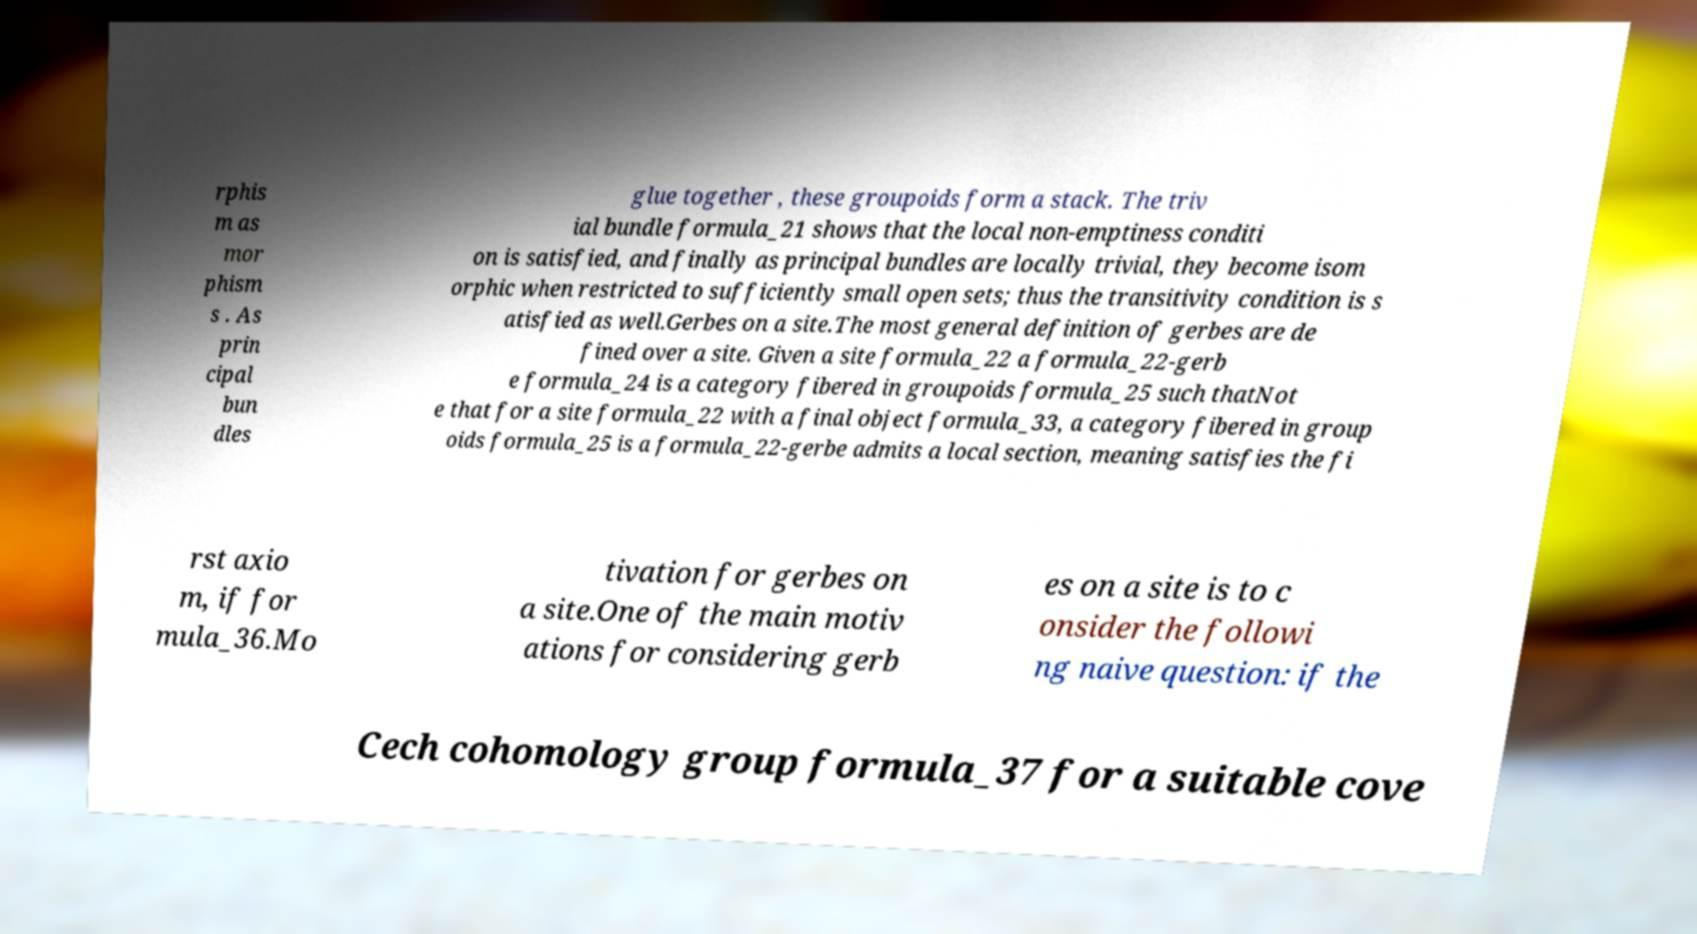I need the written content from this picture converted into text. Can you do that? rphis m as mor phism s . As prin cipal bun dles glue together , these groupoids form a stack. The triv ial bundle formula_21 shows that the local non-emptiness conditi on is satisfied, and finally as principal bundles are locally trivial, they become isom orphic when restricted to sufficiently small open sets; thus the transitivity condition is s atisfied as well.Gerbes on a site.The most general definition of gerbes are de fined over a site. Given a site formula_22 a formula_22-gerb e formula_24 is a category fibered in groupoids formula_25 such thatNot e that for a site formula_22 with a final object formula_33, a category fibered in group oids formula_25 is a formula_22-gerbe admits a local section, meaning satisfies the fi rst axio m, if for mula_36.Mo tivation for gerbes on a site.One of the main motiv ations for considering gerb es on a site is to c onsider the followi ng naive question: if the Cech cohomology group formula_37 for a suitable cove 